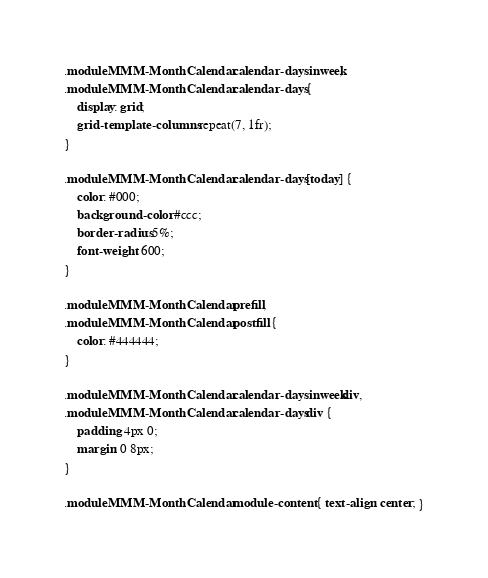<code> <loc_0><loc_0><loc_500><loc_500><_CSS_>.module.MMM-MonthCalendar .calendar-daysinweek,
.module.MMM-MonthCalendar .calendar-days {
    display: grid;
    grid-template-columns: repeat(7, 1fr);
}

.module.MMM-MonthCalendar .calendar-days [today] {
    color: #000;
    background-color: #ccc;
    border-radius: 5%;
    font-weight: 600;
}

.module.MMM-MonthCalendar .prefill,
.module.MMM-MonthCalendar .postfill {
    color: #444444;
}

.module.MMM-MonthCalendar .calendar-daysinweek div,
.module.MMM-MonthCalendar .calendar-days div {
    padding: 4px 0;
    margin: 0 8px;
}

.module.MMM-MonthCalendar .module-content { text-align: center; }
</code> 